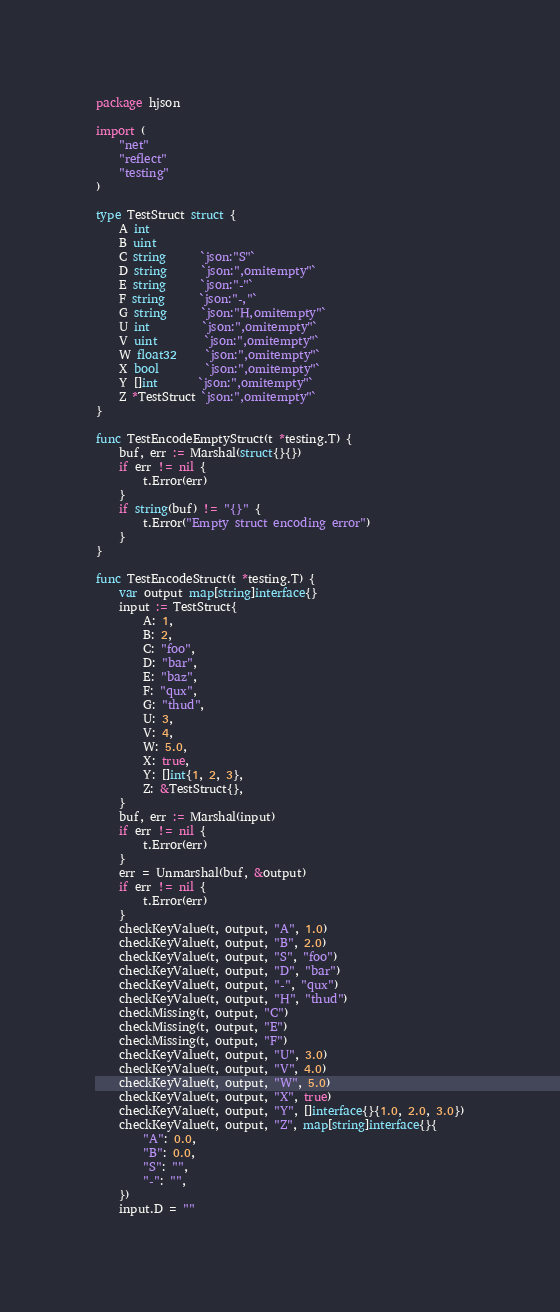<code> <loc_0><loc_0><loc_500><loc_500><_Go_>package hjson

import (
	"net"
	"reflect"
	"testing"
)

type TestStruct struct {
	A int
	B uint
	C string      `json:"S"`
	D string      `json:",omitempty"`
	E string      `json:"-"`
	F string      `json:"-,"`
	G string      `json:"H,omitempty"`
	U int         `json:",omitempty"`
	V uint        `json:",omitempty"`
	W float32     `json:",omitempty"`
	X bool        `json:",omitempty"`
	Y []int       `json:",omitempty"`
	Z *TestStruct `json:",omitempty"`
}

func TestEncodeEmptyStruct(t *testing.T) {
	buf, err := Marshal(struct{}{})
	if err != nil {
		t.Error(err)
	}
	if string(buf) != "{}" {
		t.Error("Empty struct encoding error")
	}
}

func TestEncodeStruct(t *testing.T) {
	var output map[string]interface{}
	input := TestStruct{
		A: 1,
		B: 2,
		C: "foo",
		D: "bar",
		E: "baz",
		F: "qux",
		G: "thud",
		U: 3,
		V: 4,
		W: 5.0,
		X: true,
		Y: []int{1, 2, 3},
		Z: &TestStruct{},
	}
	buf, err := Marshal(input)
	if err != nil {
		t.Error(err)
	}
	err = Unmarshal(buf, &output)
	if err != nil {
		t.Error(err)
	}
	checkKeyValue(t, output, "A", 1.0)
	checkKeyValue(t, output, "B", 2.0)
	checkKeyValue(t, output, "S", "foo")
	checkKeyValue(t, output, "D", "bar")
	checkKeyValue(t, output, "-", "qux")
	checkKeyValue(t, output, "H", "thud")
	checkMissing(t, output, "C")
	checkMissing(t, output, "E")
	checkMissing(t, output, "F")
	checkKeyValue(t, output, "U", 3.0)
	checkKeyValue(t, output, "V", 4.0)
	checkKeyValue(t, output, "W", 5.0)
	checkKeyValue(t, output, "X", true)
	checkKeyValue(t, output, "Y", []interface{}{1.0, 2.0, 3.0})
	checkKeyValue(t, output, "Z", map[string]interface{}{
		"A": 0.0,
		"B": 0.0,
		"S": "",
		"-": "",
	})
	input.D = ""</code> 